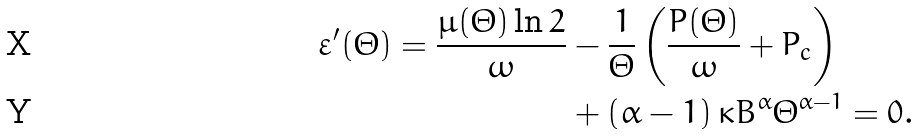<formula> <loc_0><loc_0><loc_500><loc_500>\varepsilon ^ { \prime } ( \Theta ) = \frac { \mu ( \Theta ) \ln 2 } { \omega } & - \frac { 1 } { \Theta } \left ( \frac { P ( \Theta ) } { \omega } + P _ { c } \right ) \\ & + \left ( \alpha - 1 \right ) \kappa B ^ { \alpha } \Theta ^ { \alpha - 1 } = 0 .</formula> 